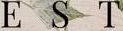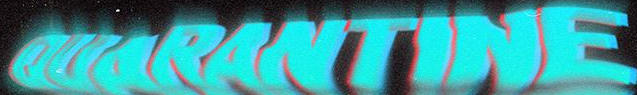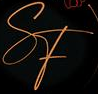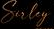What text appears in these images from left to right, separated by a semicolon? EST; OUARANTINE; SF; Suley 